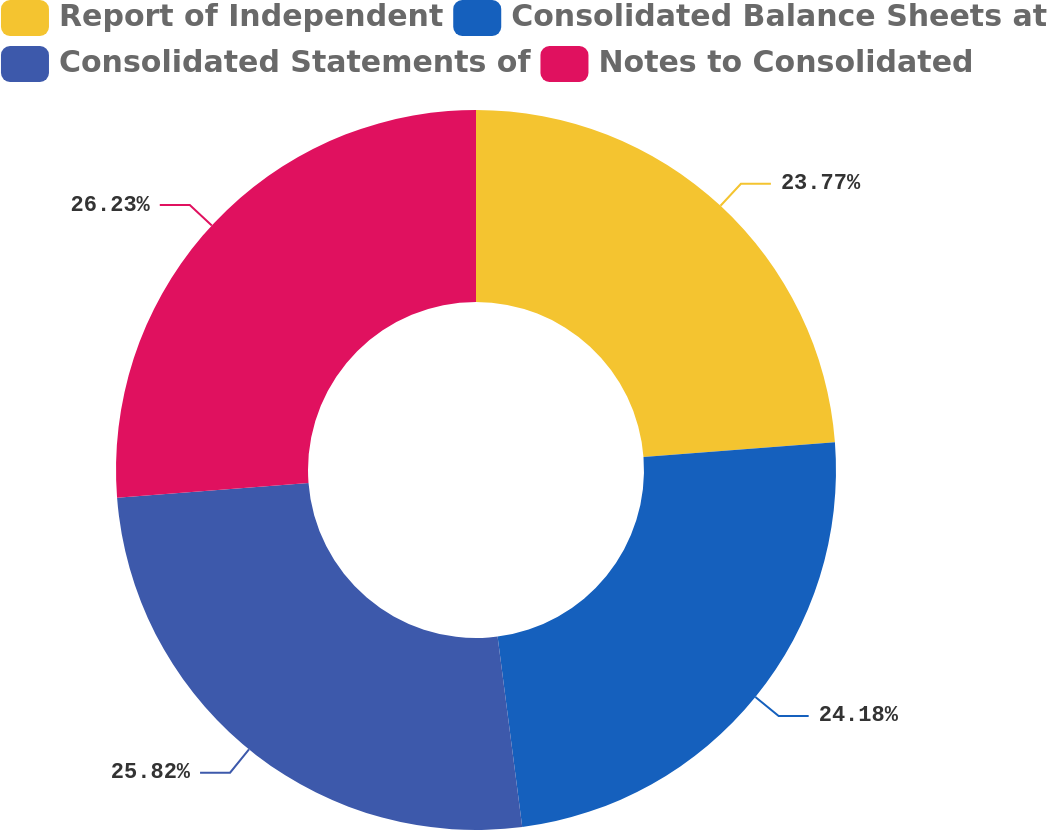Convert chart to OTSL. <chart><loc_0><loc_0><loc_500><loc_500><pie_chart><fcel>Report of Independent<fcel>Consolidated Balance Sheets at<fcel>Consolidated Statements of<fcel>Notes to Consolidated<nl><fcel>23.77%<fcel>24.18%<fcel>25.82%<fcel>26.23%<nl></chart> 